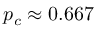<formula> <loc_0><loc_0><loc_500><loc_500>p _ { c } \approx 0 . 6 6 7</formula> 